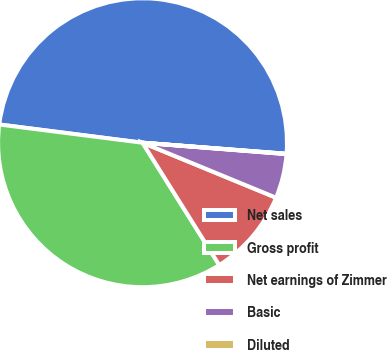Convert chart to OTSL. <chart><loc_0><loc_0><loc_500><loc_500><pie_chart><fcel>Net sales<fcel>Gross profit<fcel>Net earnings of Zimmer<fcel>Basic<fcel>Diluted<nl><fcel>49.2%<fcel>35.93%<fcel>9.87%<fcel>4.96%<fcel>0.04%<nl></chart> 